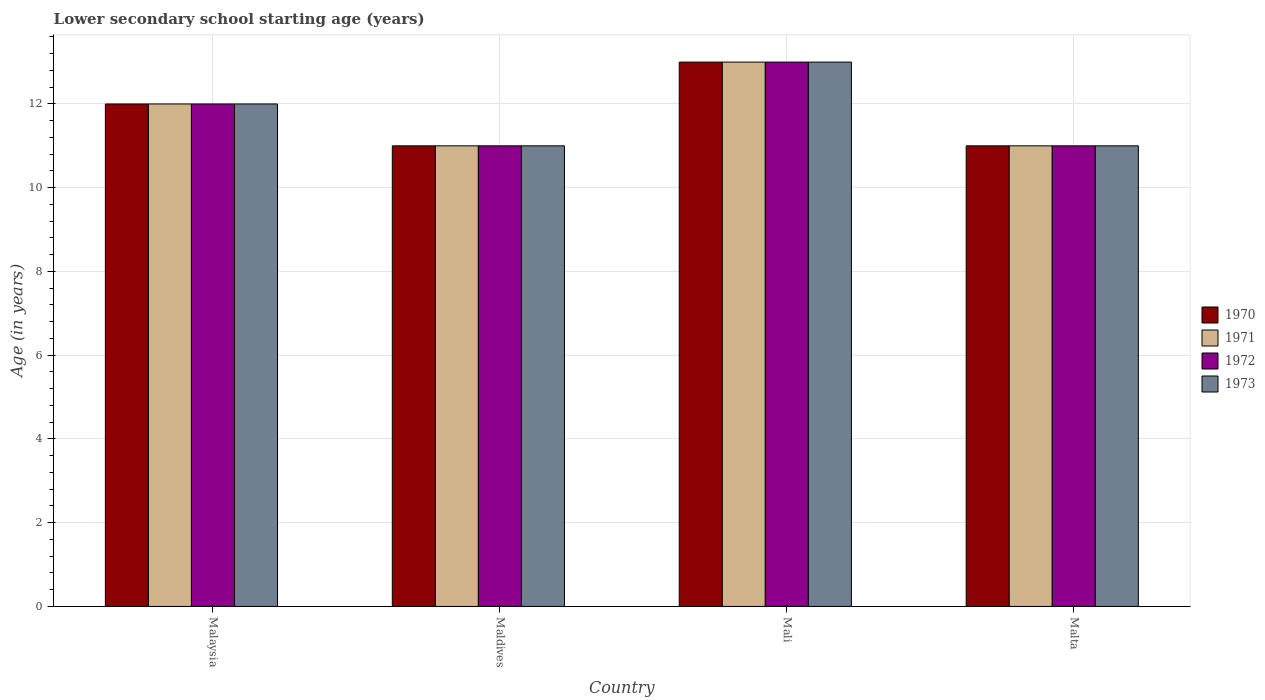How many different coloured bars are there?
Keep it short and to the point. 4. How many groups of bars are there?
Offer a terse response. 4. How many bars are there on the 3rd tick from the left?
Offer a terse response. 4. What is the label of the 4th group of bars from the left?
Make the answer very short. Malta. In how many cases, is the number of bars for a given country not equal to the number of legend labels?
Give a very brief answer. 0. What is the lower secondary school starting age of children in 1971 in Maldives?
Provide a succinct answer. 11. Across all countries, what is the minimum lower secondary school starting age of children in 1972?
Make the answer very short. 11. In which country was the lower secondary school starting age of children in 1973 maximum?
Your response must be concise. Mali. In which country was the lower secondary school starting age of children in 1971 minimum?
Your response must be concise. Maldives. What is the total lower secondary school starting age of children in 1971 in the graph?
Offer a very short reply. 47. What is the difference between the lower secondary school starting age of children in 1973 in Malta and the lower secondary school starting age of children in 1970 in Maldives?
Your response must be concise. 0. What is the average lower secondary school starting age of children in 1971 per country?
Your answer should be very brief. 11.75. What is the difference between the lower secondary school starting age of children of/in 1971 and lower secondary school starting age of children of/in 1973 in Mali?
Keep it short and to the point. 0. In how many countries, is the lower secondary school starting age of children in 1971 greater than 11.2 years?
Give a very brief answer. 2. What is the ratio of the lower secondary school starting age of children in 1971 in Maldives to that in Malta?
Offer a very short reply. 1. Is the lower secondary school starting age of children in 1971 in Mali less than that in Malta?
Your answer should be very brief. No. What is the difference between the highest and the second highest lower secondary school starting age of children in 1973?
Your answer should be very brief. -1. How many bars are there?
Ensure brevity in your answer.  16. Are all the bars in the graph horizontal?
Provide a succinct answer. No. How many legend labels are there?
Offer a terse response. 4. How are the legend labels stacked?
Offer a very short reply. Vertical. What is the title of the graph?
Provide a short and direct response. Lower secondary school starting age (years). Does "1970" appear as one of the legend labels in the graph?
Provide a short and direct response. Yes. What is the label or title of the Y-axis?
Ensure brevity in your answer.  Age (in years). What is the Age (in years) in 1970 in Malaysia?
Provide a short and direct response. 12. What is the Age (in years) in 1971 in Malaysia?
Make the answer very short. 12. What is the Age (in years) of 1972 in Malaysia?
Provide a short and direct response. 12. What is the Age (in years) of 1973 in Malaysia?
Your answer should be very brief. 12. What is the Age (in years) in 1971 in Maldives?
Your answer should be compact. 11. What is the Age (in years) of 1972 in Maldives?
Keep it short and to the point. 11. What is the Age (in years) in 1973 in Maldives?
Offer a terse response. 11. What is the Age (in years) in 1970 in Mali?
Your response must be concise. 13. What is the Age (in years) in 1971 in Mali?
Your response must be concise. 13. What is the Age (in years) of 1972 in Mali?
Offer a very short reply. 13. What is the Age (in years) in 1970 in Malta?
Your answer should be compact. 11. What is the Age (in years) in 1973 in Malta?
Offer a very short reply. 11. Across all countries, what is the maximum Age (in years) of 1970?
Your response must be concise. 13. Across all countries, what is the maximum Age (in years) in 1972?
Make the answer very short. 13. Across all countries, what is the maximum Age (in years) in 1973?
Provide a short and direct response. 13. Across all countries, what is the minimum Age (in years) in 1970?
Provide a succinct answer. 11. Across all countries, what is the minimum Age (in years) in 1971?
Give a very brief answer. 11. Across all countries, what is the minimum Age (in years) in 1973?
Provide a short and direct response. 11. What is the total Age (in years) of 1970 in the graph?
Provide a short and direct response. 47. What is the total Age (in years) of 1971 in the graph?
Your answer should be compact. 47. What is the total Age (in years) of 1972 in the graph?
Offer a very short reply. 47. What is the difference between the Age (in years) in 1970 in Malaysia and that in Maldives?
Provide a succinct answer. 1. What is the difference between the Age (in years) of 1972 in Malaysia and that in Maldives?
Make the answer very short. 1. What is the difference between the Age (in years) of 1971 in Malaysia and that in Mali?
Your answer should be very brief. -1. What is the difference between the Age (in years) of 1973 in Malaysia and that in Mali?
Provide a short and direct response. -1. What is the difference between the Age (in years) in 1970 in Malaysia and that in Malta?
Provide a short and direct response. 1. What is the difference between the Age (in years) of 1971 in Malaysia and that in Malta?
Give a very brief answer. 1. What is the difference between the Age (in years) in 1973 in Malaysia and that in Malta?
Ensure brevity in your answer.  1. What is the difference between the Age (in years) in 1970 in Maldives and that in Mali?
Offer a very short reply. -2. What is the difference between the Age (in years) in 1972 in Maldives and that in Mali?
Provide a succinct answer. -2. What is the difference between the Age (in years) in 1970 in Maldives and that in Malta?
Give a very brief answer. 0. What is the difference between the Age (in years) in 1971 in Maldives and that in Malta?
Keep it short and to the point. 0. What is the difference between the Age (in years) of 1973 in Maldives and that in Malta?
Provide a succinct answer. 0. What is the difference between the Age (in years) in 1970 in Mali and that in Malta?
Provide a short and direct response. 2. What is the difference between the Age (in years) of 1971 in Mali and that in Malta?
Provide a short and direct response. 2. What is the difference between the Age (in years) of 1972 in Mali and that in Malta?
Your answer should be compact. 2. What is the difference between the Age (in years) of 1973 in Mali and that in Malta?
Your answer should be compact. 2. What is the difference between the Age (in years) of 1970 in Malaysia and the Age (in years) of 1972 in Maldives?
Provide a succinct answer. 1. What is the difference between the Age (in years) of 1971 in Malaysia and the Age (in years) of 1973 in Maldives?
Offer a very short reply. 1. What is the difference between the Age (in years) in 1970 in Malaysia and the Age (in years) in 1972 in Mali?
Ensure brevity in your answer.  -1. What is the difference between the Age (in years) of 1971 in Malaysia and the Age (in years) of 1972 in Mali?
Offer a terse response. -1. What is the difference between the Age (in years) of 1971 in Malaysia and the Age (in years) of 1973 in Mali?
Provide a short and direct response. -1. What is the difference between the Age (in years) in 1970 in Malaysia and the Age (in years) in 1971 in Malta?
Offer a terse response. 1. What is the difference between the Age (in years) of 1970 in Malaysia and the Age (in years) of 1972 in Malta?
Make the answer very short. 1. What is the difference between the Age (in years) in 1970 in Malaysia and the Age (in years) in 1973 in Malta?
Give a very brief answer. 1. What is the difference between the Age (in years) of 1971 in Malaysia and the Age (in years) of 1973 in Malta?
Your response must be concise. 1. What is the difference between the Age (in years) in 1970 in Maldives and the Age (in years) in 1972 in Mali?
Offer a very short reply. -2. What is the difference between the Age (in years) in 1971 in Maldives and the Age (in years) in 1972 in Mali?
Your answer should be very brief. -2. What is the difference between the Age (in years) of 1971 in Maldives and the Age (in years) of 1973 in Mali?
Your answer should be compact. -2. What is the difference between the Age (in years) in 1970 in Maldives and the Age (in years) in 1971 in Malta?
Keep it short and to the point. 0. What is the difference between the Age (in years) in 1970 in Maldives and the Age (in years) in 1973 in Malta?
Your answer should be compact. 0. What is the difference between the Age (in years) of 1971 in Maldives and the Age (in years) of 1973 in Malta?
Keep it short and to the point. 0. What is the difference between the Age (in years) of 1972 in Maldives and the Age (in years) of 1973 in Malta?
Provide a succinct answer. 0. What is the difference between the Age (in years) of 1970 in Mali and the Age (in years) of 1971 in Malta?
Give a very brief answer. 2. What is the difference between the Age (in years) in 1970 in Mali and the Age (in years) in 1972 in Malta?
Provide a short and direct response. 2. What is the difference between the Age (in years) of 1970 in Mali and the Age (in years) of 1973 in Malta?
Ensure brevity in your answer.  2. What is the difference between the Age (in years) of 1972 in Mali and the Age (in years) of 1973 in Malta?
Make the answer very short. 2. What is the average Age (in years) of 1970 per country?
Provide a short and direct response. 11.75. What is the average Age (in years) of 1971 per country?
Offer a terse response. 11.75. What is the average Age (in years) in 1972 per country?
Offer a very short reply. 11.75. What is the average Age (in years) in 1973 per country?
Offer a terse response. 11.75. What is the difference between the Age (in years) in 1970 and Age (in years) in 1972 in Malaysia?
Offer a terse response. 0. What is the difference between the Age (in years) of 1971 and Age (in years) of 1972 in Malaysia?
Give a very brief answer. 0. What is the difference between the Age (in years) of 1971 and Age (in years) of 1973 in Malaysia?
Keep it short and to the point. 0. What is the difference between the Age (in years) in 1972 and Age (in years) in 1973 in Malaysia?
Keep it short and to the point. 0. What is the difference between the Age (in years) in 1971 and Age (in years) in 1972 in Maldives?
Keep it short and to the point. 0. What is the difference between the Age (in years) of 1971 and Age (in years) of 1973 in Maldives?
Your answer should be compact. 0. What is the difference between the Age (in years) of 1972 and Age (in years) of 1973 in Maldives?
Provide a short and direct response. 0. What is the difference between the Age (in years) in 1970 and Age (in years) in 1971 in Mali?
Offer a terse response. 0. What is the difference between the Age (in years) of 1970 and Age (in years) of 1972 in Mali?
Offer a terse response. 0. What is the difference between the Age (in years) of 1970 and Age (in years) of 1973 in Mali?
Your answer should be compact. 0. What is the difference between the Age (in years) of 1972 and Age (in years) of 1973 in Mali?
Ensure brevity in your answer.  0. What is the difference between the Age (in years) of 1970 and Age (in years) of 1971 in Malta?
Give a very brief answer. 0. What is the difference between the Age (in years) in 1970 and Age (in years) in 1972 in Malta?
Provide a short and direct response. 0. What is the difference between the Age (in years) in 1970 and Age (in years) in 1973 in Malta?
Provide a short and direct response. 0. What is the difference between the Age (in years) in 1971 and Age (in years) in 1973 in Malta?
Ensure brevity in your answer.  0. What is the difference between the Age (in years) in 1972 and Age (in years) in 1973 in Malta?
Offer a terse response. 0. What is the ratio of the Age (in years) in 1970 in Malaysia to that in Maldives?
Provide a short and direct response. 1.09. What is the ratio of the Age (in years) in 1971 in Malaysia to that in Maldives?
Give a very brief answer. 1.09. What is the ratio of the Age (in years) in 1972 in Malaysia to that in Maldives?
Make the answer very short. 1.09. What is the ratio of the Age (in years) of 1971 in Malaysia to that in Mali?
Keep it short and to the point. 0.92. What is the ratio of the Age (in years) of 1973 in Malaysia to that in Mali?
Provide a succinct answer. 0.92. What is the ratio of the Age (in years) of 1970 in Malaysia to that in Malta?
Offer a terse response. 1.09. What is the ratio of the Age (in years) of 1971 in Malaysia to that in Malta?
Your answer should be very brief. 1.09. What is the ratio of the Age (in years) in 1970 in Maldives to that in Mali?
Give a very brief answer. 0.85. What is the ratio of the Age (in years) of 1971 in Maldives to that in Mali?
Ensure brevity in your answer.  0.85. What is the ratio of the Age (in years) of 1972 in Maldives to that in Mali?
Your response must be concise. 0.85. What is the ratio of the Age (in years) of 1973 in Maldives to that in Mali?
Your answer should be compact. 0.85. What is the ratio of the Age (in years) of 1971 in Maldives to that in Malta?
Offer a very short reply. 1. What is the ratio of the Age (in years) of 1973 in Maldives to that in Malta?
Make the answer very short. 1. What is the ratio of the Age (in years) of 1970 in Mali to that in Malta?
Give a very brief answer. 1.18. What is the ratio of the Age (in years) of 1971 in Mali to that in Malta?
Make the answer very short. 1.18. What is the ratio of the Age (in years) in 1972 in Mali to that in Malta?
Your answer should be compact. 1.18. What is the ratio of the Age (in years) in 1973 in Mali to that in Malta?
Ensure brevity in your answer.  1.18. What is the difference between the highest and the second highest Age (in years) of 1970?
Give a very brief answer. 1. What is the difference between the highest and the second highest Age (in years) in 1973?
Give a very brief answer. 1. What is the difference between the highest and the lowest Age (in years) in 1971?
Your answer should be very brief. 2. What is the difference between the highest and the lowest Age (in years) of 1972?
Give a very brief answer. 2. What is the difference between the highest and the lowest Age (in years) in 1973?
Provide a short and direct response. 2. 